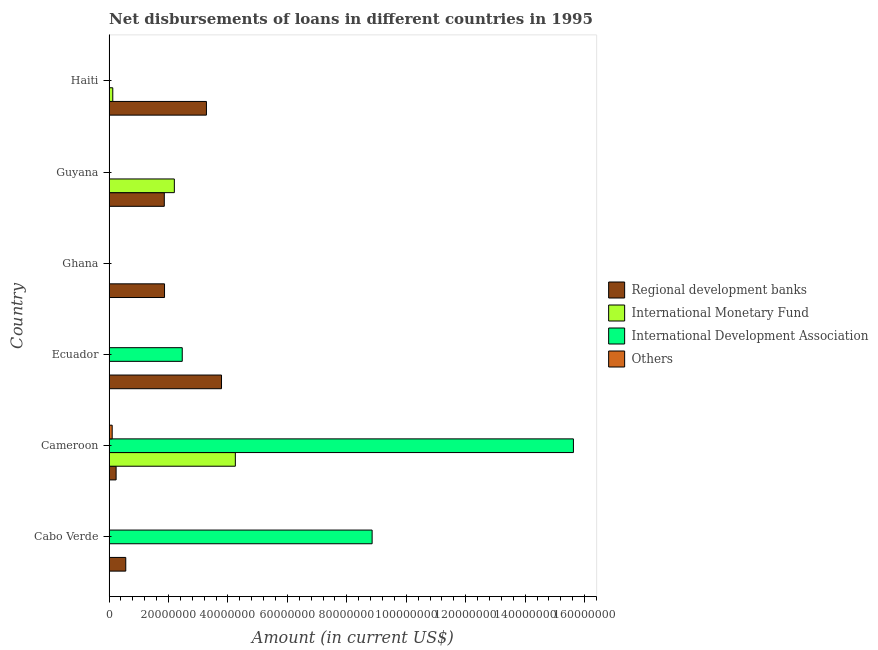How many different coloured bars are there?
Your answer should be compact. 4. What is the label of the 2nd group of bars from the top?
Offer a terse response. Guyana. What is the amount of loan disimbursed by international development association in Guyana?
Offer a terse response. 2.70e+04. Across all countries, what is the maximum amount of loan disimbursed by regional development banks?
Offer a terse response. 3.78e+07. In which country was the amount of loan disimbursed by international development association maximum?
Provide a succinct answer. Cameroon. What is the total amount of loan disimbursed by international development association in the graph?
Make the answer very short. 2.69e+08. What is the difference between the amount of loan disimbursed by regional development banks in Ecuador and that in Haiti?
Provide a succinct answer. 5.07e+06. What is the difference between the amount of loan disimbursed by international monetary fund in Guyana and the amount of loan disimbursed by international development association in Ghana?
Provide a succinct answer. 2.20e+07. What is the average amount of loan disimbursed by international monetary fund per country?
Offer a terse response. 1.09e+07. What is the difference between the amount of loan disimbursed by international monetary fund and amount of loan disimbursed by regional development banks in Haiti?
Provide a succinct answer. -3.15e+07. In how many countries, is the amount of loan disimbursed by regional development banks greater than 136000000 US$?
Keep it short and to the point. 0. What is the ratio of the amount of loan disimbursed by regional development banks in Ghana to that in Haiti?
Your answer should be very brief. 0.57. Is the amount of loan disimbursed by regional development banks in Cabo Verde less than that in Ecuador?
Provide a short and direct response. Yes. What is the difference between the highest and the second highest amount of loan disimbursed by international monetary fund?
Your answer should be compact. 2.05e+07. What is the difference between the highest and the lowest amount of loan disimbursed by international monetary fund?
Provide a short and direct response. 4.25e+07. Is the sum of the amount of loan disimbursed by regional development banks in Ecuador and Ghana greater than the maximum amount of loan disimbursed by international development association across all countries?
Your answer should be compact. No. Is it the case that in every country, the sum of the amount of loan disimbursed by international development association and amount of loan disimbursed by other organisations is greater than the sum of amount of loan disimbursed by international monetary fund and amount of loan disimbursed by regional development banks?
Make the answer very short. No. Is it the case that in every country, the sum of the amount of loan disimbursed by regional development banks and amount of loan disimbursed by international monetary fund is greater than the amount of loan disimbursed by international development association?
Keep it short and to the point. No. Are all the bars in the graph horizontal?
Give a very brief answer. Yes. How many countries are there in the graph?
Provide a succinct answer. 6. What is the difference between two consecutive major ticks on the X-axis?
Offer a very short reply. 2.00e+07. Does the graph contain grids?
Provide a short and direct response. No. Where does the legend appear in the graph?
Keep it short and to the point. Center right. What is the title of the graph?
Make the answer very short. Net disbursements of loans in different countries in 1995. Does "Tertiary schools" appear as one of the legend labels in the graph?
Ensure brevity in your answer.  No. What is the label or title of the X-axis?
Keep it short and to the point. Amount (in current US$). What is the Amount (in current US$) of Regional development banks in Cabo Verde?
Your answer should be compact. 5.62e+06. What is the Amount (in current US$) in International Development Association in Cabo Verde?
Provide a succinct answer. 8.85e+07. What is the Amount (in current US$) in Regional development banks in Cameroon?
Make the answer very short. 2.37e+06. What is the Amount (in current US$) of International Monetary Fund in Cameroon?
Offer a very short reply. 4.25e+07. What is the Amount (in current US$) of International Development Association in Cameroon?
Provide a succinct answer. 1.56e+08. What is the Amount (in current US$) in Others in Cameroon?
Provide a short and direct response. 1.05e+06. What is the Amount (in current US$) of Regional development banks in Ecuador?
Ensure brevity in your answer.  3.78e+07. What is the Amount (in current US$) of International Monetary Fund in Ecuador?
Your answer should be compact. 0. What is the Amount (in current US$) in International Development Association in Ecuador?
Offer a very short reply. 2.46e+07. What is the Amount (in current US$) of Others in Ecuador?
Provide a succinct answer. 0. What is the Amount (in current US$) of Regional development banks in Ghana?
Your response must be concise. 1.87e+07. What is the Amount (in current US$) of International Monetary Fund in Ghana?
Your answer should be compact. 0. What is the Amount (in current US$) of Regional development banks in Guyana?
Offer a very short reply. 1.86e+07. What is the Amount (in current US$) of International Monetary Fund in Guyana?
Your answer should be very brief. 2.20e+07. What is the Amount (in current US$) in International Development Association in Guyana?
Offer a very short reply. 2.70e+04. What is the Amount (in current US$) in Others in Guyana?
Keep it short and to the point. 0. What is the Amount (in current US$) in Regional development banks in Haiti?
Ensure brevity in your answer.  3.28e+07. What is the Amount (in current US$) of International Monetary Fund in Haiti?
Your answer should be very brief. 1.25e+06. What is the Amount (in current US$) in International Development Association in Haiti?
Your answer should be very brief. 0. Across all countries, what is the maximum Amount (in current US$) in Regional development banks?
Your answer should be very brief. 3.78e+07. Across all countries, what is the maximum Amount (in current US$) in International Monetary Fund?
Give a very brief answer. 4.25e+07. Across all countries, what is the maximum Amount (in current US$) in International Development Association?
Your answer should be compact. 1.56e+08. Across all countries, what is the maximum Amount (in current US$) of Others?
Give a very brief answer. 1.05e+06. Across all countries, what is the minimum Amount (in current US$) in Regional development banks?
Your response must be concise. 2.37e+06. Across all countries, what is the minimum Amount (in current US$) of International Monetary Fund?
Keep it short and to the point. 0. Across all countries, what is the minimum Amount (in current US$) of Others?
Your answer should be very brief. 0. What is the total Amount (in current US$) in Regional development banks in the graph?
Ensure brevity in your answer.  1.16e+08. What is the total Amount (in current US$) of International Monetary Fund in the graph?
Offer a terse response. 6.57e+07. What is the total Amount (in current US$) of International Development Association in the graph?
Make the answer very short. 2.69e+08. What is the total Amount (in current US$) in Others in the graph?
Your answer should be compact. 1.05e+06. What is the difference between the Amount (in current US$) of Regional development banks in Cabo Verde and that in Cameroon?
Ensure brevity in your answer.  3.25e+06. What is the difference between the Amount (in current US$) in International Development Association in Cabo Verde and that in Cameroon?
Provide a succinct answer. -6.77e+07. What is the difference between the Amount (in current US$) in Regional development banks in Cabo Verde and that in Ecuador?
Provide a succinct answer. -3.22e+07. What is the difference between the Amount (in current US$) of International Development Association in Cabo Verde and that in Ecuador?
Ensure brevity in your answer.  6.39e+07. What is the difference between the Amount (in current US$) of Regional development banks in Cabo Verde and that in Ghana?
Offer a terse response. -1.30e+07. What is the difference between the Amount (in current US$) of Regional development banks in Cabo Verde and that in Guyana?
Your answer should be compact. -1.30e+07. What is the difference between the Amount (in current US$) of International Development Association in Cabo Verde and that in Guyana?
Your response must be concise. 8.85e+07. What is the difference between the Amount (in current US$) in Regional development banks in Cabo Verde and that in Haiti?
Offer a terse response. -2.71e+07. What is the difference between the Amount (in current US$) in Regional development banks in Cameroon and that in Ecuador?
Your answer should be compact. -3.55e+07. What is the difference between the Amount (in current US$) of International Development Association in Cameroon and that in Ecuador?
Ensure brevity in your answer.  1.32e+08. What is the difference between the Amount (in current US$) in Regional development banks in Cameroon and that in Ghana?
Give a very brief answer. -1.63e+07. What is the difference between the Amount (in current US$) in Regional development banks in Cameroon and that in Guyana?
Provide a succinct answer. -1.62e+07. What is the difference between the Amount (in current US$) in International Monetary Fund in Cameroon and that in Guyana?
Make the answer very short. 2.05e+07. What is the difference between the Amount (in current US$) in International Development Association in Cameroon and that in Guyana?
Offer a terse response. 1.56e+08. What is the difference between the Amount (in current US$) of Regional development banks in Cameroon and that in Haiti?
Give a very brief answer. -3.04e+07. What is the difference between the Amount (in current US$) in International Monetary Fund in Cameroon and that in Haiti?
Keep it short and to the point. 4.12e+07. What is the difference between the Amount (in current US$) of Regional development banks in Ecuador and that in Ghana?
Your response must be concise. 1.92e+07. What is the difference between the Amount (in current US$) of Regional development banks in Ecuador and that in Guyana?
Offer a very short reply. 1.93e+07. What is the difference between the Amount (in current US$) in International Development Association in Ecuador and that in Guyana?
Your response must be concise. 2.46e+07. What is the difference between the Amount (in current US$) of Regional development banks in Ecuador and that in Haiti?
Offer a very short reply. 5.07e+06. What is the difference between the Amount (in current US$) in Regional development banks in Ghana and that in Guyana?
Your answer should be very brief. 7.80e+04. What is the difference between the Amount (in current US$) in Regional development banks in Ghana and that in Haiti?
Offer a terse response. -1.41e+07. What is the difference between the Amount (in current US$) of Regional development banks in Guyana and that in Haiti?
Your answer should be very brief. -1.42e+07. What is the difference between the Amount (in current US$) of International Monetary Fund in Guyana and that in Haiti?
Your answer should be very brief. 2.07e+07. What is the difference between the Amount (in current US$) of Regional development banks in Cabo Verde and the Amount (in current US$) of International Monetary Fund in Cameroon?
Offer a terse response. -3.69e+07. What is the difference between the Amount (in current US$) of Regional development banks in Cabo Verde and the Amount (in current US$) of International Development Association in Cameroon?
Make the answer very short. -1.51e+08. What is the difference between the Amount (in current US$) in Regional development banks in Cabo Verde and the Amount (in current US$) in Others in Cameroon?
Offer a terse response. 4.56e+06. What is the difference between the Amount (in current US$) in International Development Association in Cabo Verde and the Amount (in current US$) in Others in Cameroon?
Make the answer very short. 8.74e+07. What is the difference between the Amount (in current US$) in Regional development banks in Cabo Verde and the Amount (in current US$) in International Development Association in Ecuador?
Give a very brief answer. -1.90e+07. What is the difference between the Amount (in current US$) of Regional development banks in Cabo Verde and the Amount (in current US$) of International Monetary Fund in Guyana?
Provide a short and direct response. -1.63e+07. What is the difference between the Amount (in current US$) of Regional development banks in Cabo Verde and the Amount (in current US$) of International Development Association in Guyana?
Provide a short and direct response. 5.59e+06. What is the difference between the Amount (in current US$) of Regional development banks in Cabo Verde and the Amount (in current US$) of International Monetary Fund in Haiti?
Your response must be concise. 4.36e+06. What is the difference between the Amount (in current US$) in Regional development banks in Cameroon and the Amount (in current US$) in International Development Association in Ecuador?
Provide a short and direct response. -2.23e+07. What is the difference between the Amount (in current US$) in International Monetary Fund in Cameroon and the Amount (in current US$) in International Development Association in Ecuador?
Offer a very short reply. 1.79e+07. What is the difference between the Amount (in current US$) of Regional development banks in Cameroon and the Amount (in current US$) of International Monetary Fund in Guyana?
Provide a succinct answer. -1.96e+07. What is the difference between the Amount (in current US$) of Regional development banks in Cameroon and the Amount (in current US$) of International Development Association in Guyana?
Offer a very short reply. 2.34e+06. What is the difference between the Amount (in current US$) of International Monetary Fund in Cameroon and the Amount (in current US$) of International Development Association in Guyana?
Your answer should be very brief. 4.25e+07. What is the difference between the Amount (in current US$) of Regional development banks in Cameroon and the Amount (in current US$) of International Monetary Fund in Haiti?
Give a very brief answer. 1.12e+06. What is the difference between the Amount (in current US$) in Regional development banks in Ecuador and the Amount (in current US$) in International Monetary Fund in Guyana?
Provide a succinct answer. 1.59e+07. What is the difference between the Amount (in current US$) of Regional development banks in Ecuador and the Amount (in current US$) of International Development Association in Guyana?
Give a very brief answer. 3.78e+07. What is the difference between the Amount (in current US$) of Regional development banks in Ecuador and the Amount (in current US$) of International Monetary Fund in Haiti?
Your response must be concise. 3.66e+07. What is the difference between the Amount (in current US$) in Regional development banks in Ghana and the Amount (in current US$) in International Monetary Fund in Guyana?
Keep it short and to the point. -3.30e+06. What is the difference between the Amount (in current US$) in Regional development banks in Ghana and the Amount (in current US$) in International Development Association in Guyana?
Your answer should be very brief. 1.86e+07. What is the difference between the Amount (in current US$) in Regional development banks in Ghana and the Amount (in current US$) in International Monetary Fund in Haiti?
Offer a very short reply. 1.74e+07. What is the difference between the Amount (in current US$) in Regional development banks in Guyana and the Amount (in current US$) in International Monetary Fund in Haiti?
Provide a short and direct response. 1.73e+07. What is the average Amount (in current US$) of Regional development banks per country?
Provide a short and direct response. 1.93e+07. What is the average Amount (in current US$) in International Monetary Fund per country?
Provide a short and direct response. 1.09e+07. What is the average Amount (in current US$) in International Development Association per country?
Your response must be concise. 4.49e+07. What is the average Amount (in current US$) of Others per country?
Provide a short and direct response. 1.75e+05. What is the difference between the Amount (in current US$) in Regional development banks and Amount (in current US$) in International Development Association in Cabo Verde?
Ensure brevity in your answer.  -8.29e+07. What is the difference between the Amount (in current US$) of Regional development banks and Amount (in current US$) of International Monetary Fund in Cameroon?
Give a very brief answer. -4.01e+07. What is the difference between the Amount (in current US$) of Regional development banks and Amount (in current US$) of International Development Association in Cameroon?
Make the answer very short. -1.54e+08. What is the difference between the Amount (in current US$) in Regional development banks and Amount (in current US$) in Others in Cameroon?
Provide a succinct answer. 1.32e+06. What is the difference between the Amount (in current US$) of International Monetary Fund and Amount (in current US$) of International Development Association in Cameroon?
Your answer should be compact. -1.14e+08. What is the difference between the Amount (in current US$) of International Monetary Fund and Amount (in current US$) of Others in Cameroon?
Ensure brevity in your answer.  4.14e+07. What is the difference between the Amount (in current US$) in International Development Association and Amount (in current US$) in Others in Cameroon?
Offer a very short reply. 1.55e+08. What is the difference between the Amount (in current US$) of Regional development banks and Amount (in current US$) of International Development Association in Ecuador?
Offer a terse response. 1.32e+07. What is the difference between the Amount (in current US$) in Regional development banks and Amount (in current US$) in International Monetary Fund in Guyana?
Offer a terse response. -3.38e+06. What is the difference between the Amount (in current US$) in Regional development banks and Amount (in current US$) in International Development Association in Guyana?
Keep it short and to the point. 1.86e+07. What is the difference between the Amount (in current US$) in International Monetary Fund and Amount (in current US$) in International Development Association in Guyana?
Your response must be concise. 2.19e+07. What is the difference between the Amount (in current US$) of Regional development banks and Amount (in current US$) of International Monetary Fund in Haiti?
Offer a very short reply. 3.15e+07. What is the ratio of the Amount (in current US$) of Regional development banks in Cabo Verde to that in Cameroon?
Your response must be concise. 2.37. What is the ratio of the Amount (in current US$) of International Development Association in Cabo Verde to that in Cameroon?
Keep it short and to the point. 0.57. What is the ratio of the Amount (in current US$) of Regional development banks in Cabo Verde to that in Ecuador?
Your answer should be very brief. 0.15. What is the ratio of the Amount (in current US$) of International Development Association in Cabo Verde to that in Ecuador?
Make the answer very short. 3.59. What is the ratio of the Amount (in current US$) in Regional development banks in Cabo Verde to that in Ghana?
Your response must be concise. 0.3. What is the ratio of the Amount (in current US$) of Regional development banks in Cabo Verde to that in Guyana?
Your response must be concise. 0.3. What is the ratio of the Amount (in current US$) in International Development Association in Cabo Verde to that in Guyana?
Provide a succinct answer. 3277.7. What is the ratio of the Amount (in current US$) in Regional development banks in Cabo Verde to that in Haiti?
Provide a succinct answer. 0.17. What is the ratio of the Amount (in current US$) in Regional development banks in Cameroon to that in Ecuador?
Offer a very short reply. 0.06. What is the ratio of the Amount (in current US$) in International Development Association in Cameroon to that in Ecuador?
Provide a succinct answer. 6.34. What is the ratio of the Amount (in current US$) of Regional development banks in Cameroon to that in Ghana?
Keep it short and to the point. 0.13. What is the ratio of the Amount (in current US$) of Regional development banks in Cameroon to that in Guyana?
Ensure brevity in your answer.  0.13. What is the ratio of the Amount (in current US$) in International Monetary Fund in Cameroon to that in Guyana?
Provide a succinct answer. 1.93. What is the ratio of the Amount (in current US$) of International Development Association in Cameroon to that in Guyana?
Keep it short and to the point. 5785.85. What is the ratio of the Amount (in current US$) in Regional development banks in Cameroon to that in Haiti?
Your answer should be compact. 0.07. What is the ratio of the Amount (in current US$) of International Monetary Fund in Cameroon to that in Haiti?
Provide a succinct answer. 33.93. What is the ratio of the Amount (in current US$) in Regional development banks in Ecuador to that in Ghana?
Give a very brief answer. 2.03. What is the ratio of the Amount (in current US$) in Regional development banks in Ecuador to that in Guyana?
Ensure brevity in your answer.  2.04. What is the ratio of the Amount (in current US$) of International Development Association in Ecuador to that in Guyana?
Give a very brief answer. 911.96. What is the ratio of the Amount (in current US$) in Regional development banks in Ecuador to that in Haiti?
Make the answer very short. 1.15. What is the ratio of the Amount (in current US$) of Regional development banks in Ghana to that in Haiti?
Keep it short and to the point. 0.57. What is the ratio of the Amount (in current US$) of Regional development banks in Guyana to that in Haiti?
Give a very brief answer. 0.57. What is the ratio of the Amount (in current US$) of International Monetary Fund in Guyana to that in Haiti?
Make the answer very short. 17.54. What is the difference between the highest and the second highest Amount (in current US$) in Regional development banks?
Offer a terse response. 5.07e+06. What is the difference between the highest and the second highest Amount (in current US$) of International Monetary Fund?
Offer a very short reply. 2.05e+07. What is the difference between the highest and the second highest Amount (in current US$) in International Development Association?
Ensure brevity in your answer.  6.77e+07. What is the difference between the highest and the lowest Amount (in current US$) in Regional development banks?
Provide a succinct answer. 3.55e+07. What is the difference between the highest and the lowest Amount (in current US$) in International Monetary Fund?
Provide a succinct answer. 4.25e+07. What is the difference between the highest and the lowest Amount (in current US$) in International Development Association?
Provide a succinct answer. 1.56e+08. What is the difference between the highest and the lowest Amount (in current US$) in Others?
Your answer should be very brief. 1.05e+06. 